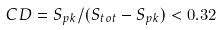Convert formula to latex. <formula><loc_0><loc_0><loc_500><loc_500>C D = S _ { p k } / ( S _ { t o t } - S _ { p k } ) < 0 . 3 2</formula> 